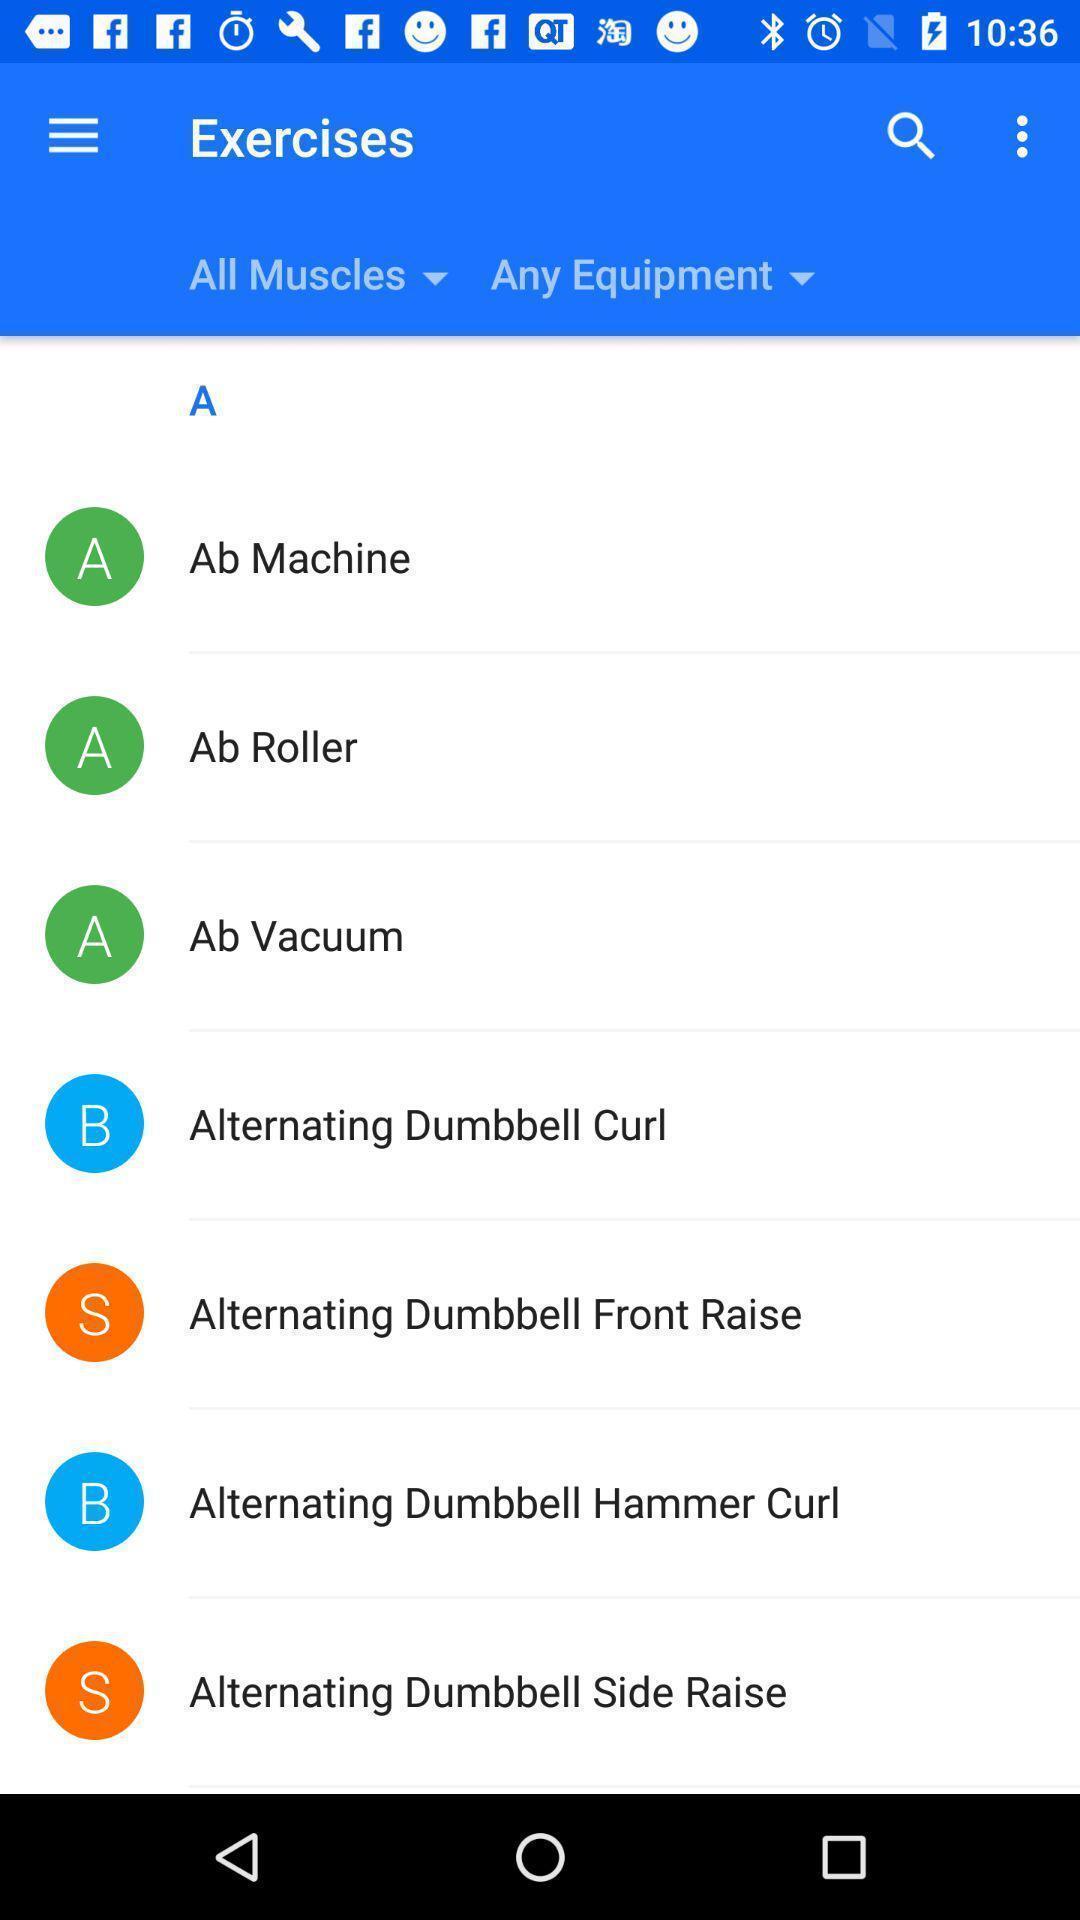Provide a detailed account of this screenshot. Page showing list of exercises in a fitness app. 